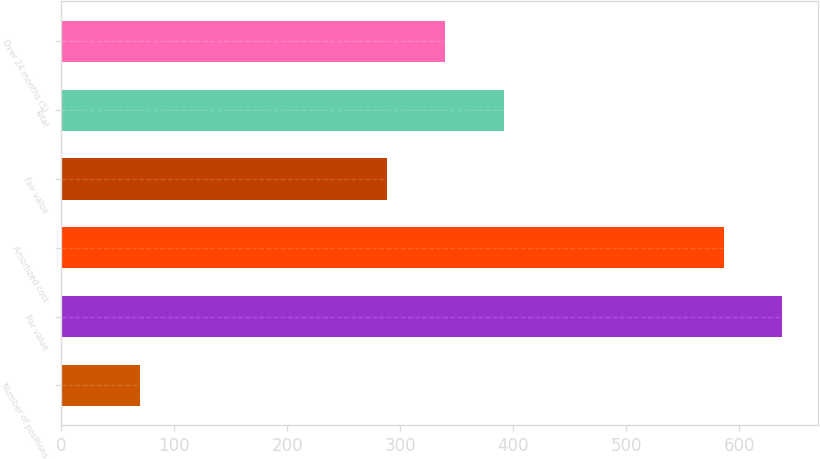<chart> <loc_0><loc_0><loc_500><loc_500><bar_chart><fcel>Number of positions<fcel>Par value<fcel>Amortized cost<fcel>Fair value<fcel>Total<fcel>Over 24 months (5)<nl><fcel>70<fcel>637.7<fcel>586<fcel>288<fcel>391.4<fcel>339.7<nl></chart> 